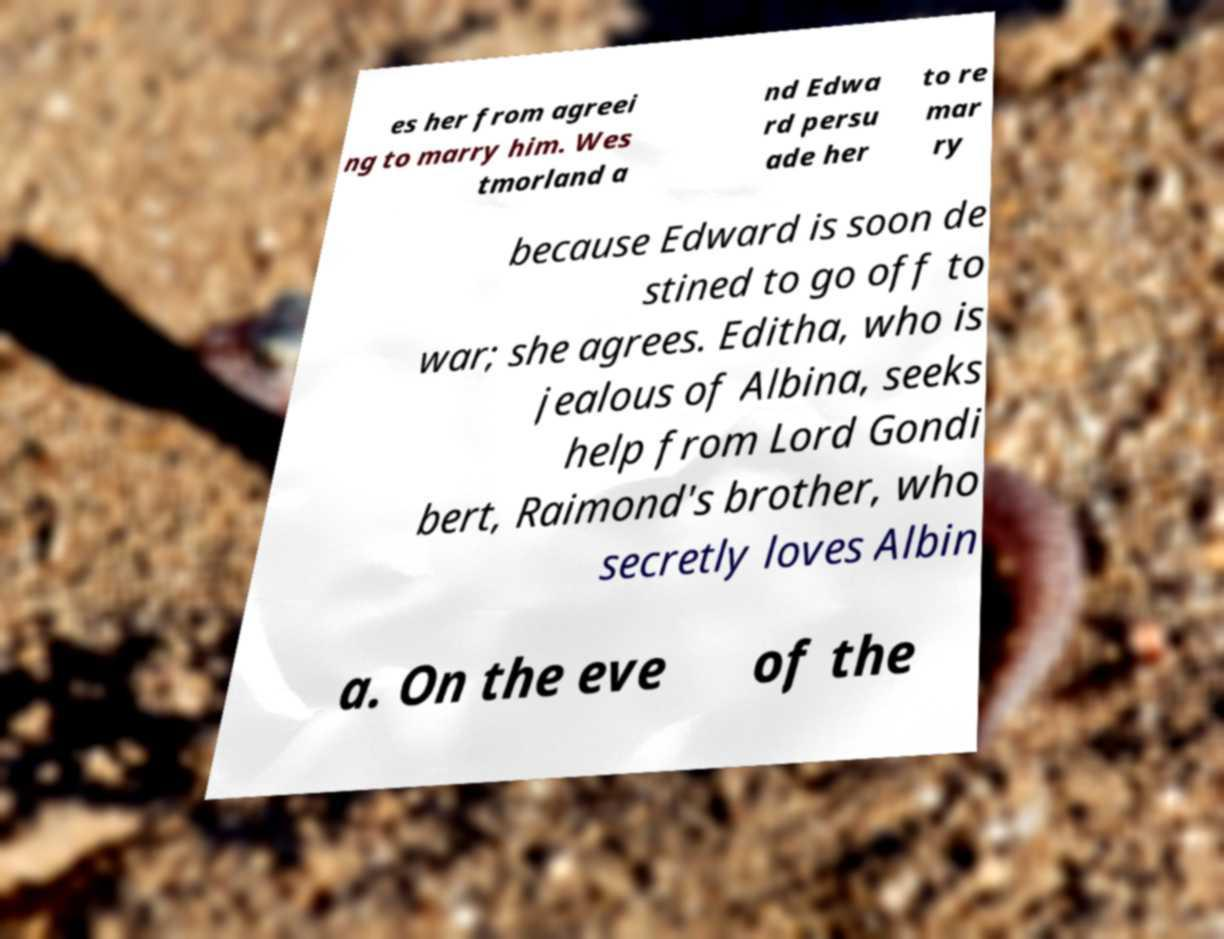Can you accurately transcribe the text from the provided image for me? es her from agreei ng to marry him. Wes tmorland a nd Edwa rd persu ade her to re mar ry because Edward is soon de stined to go off to war; she agrees. Editha, who is jealous of Albina, seeks help from Lord Gondi bert, Raimond's brother, who secretly loves Albin a. On the eve of the 